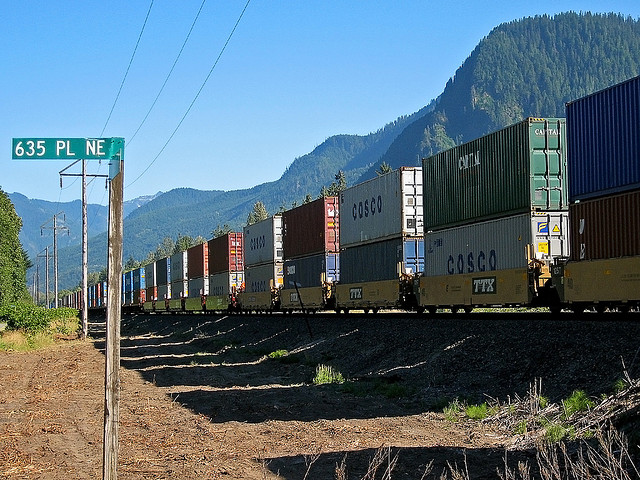Read all the text in this image. 635 PL NE COSCO TTX COSCO TTX 